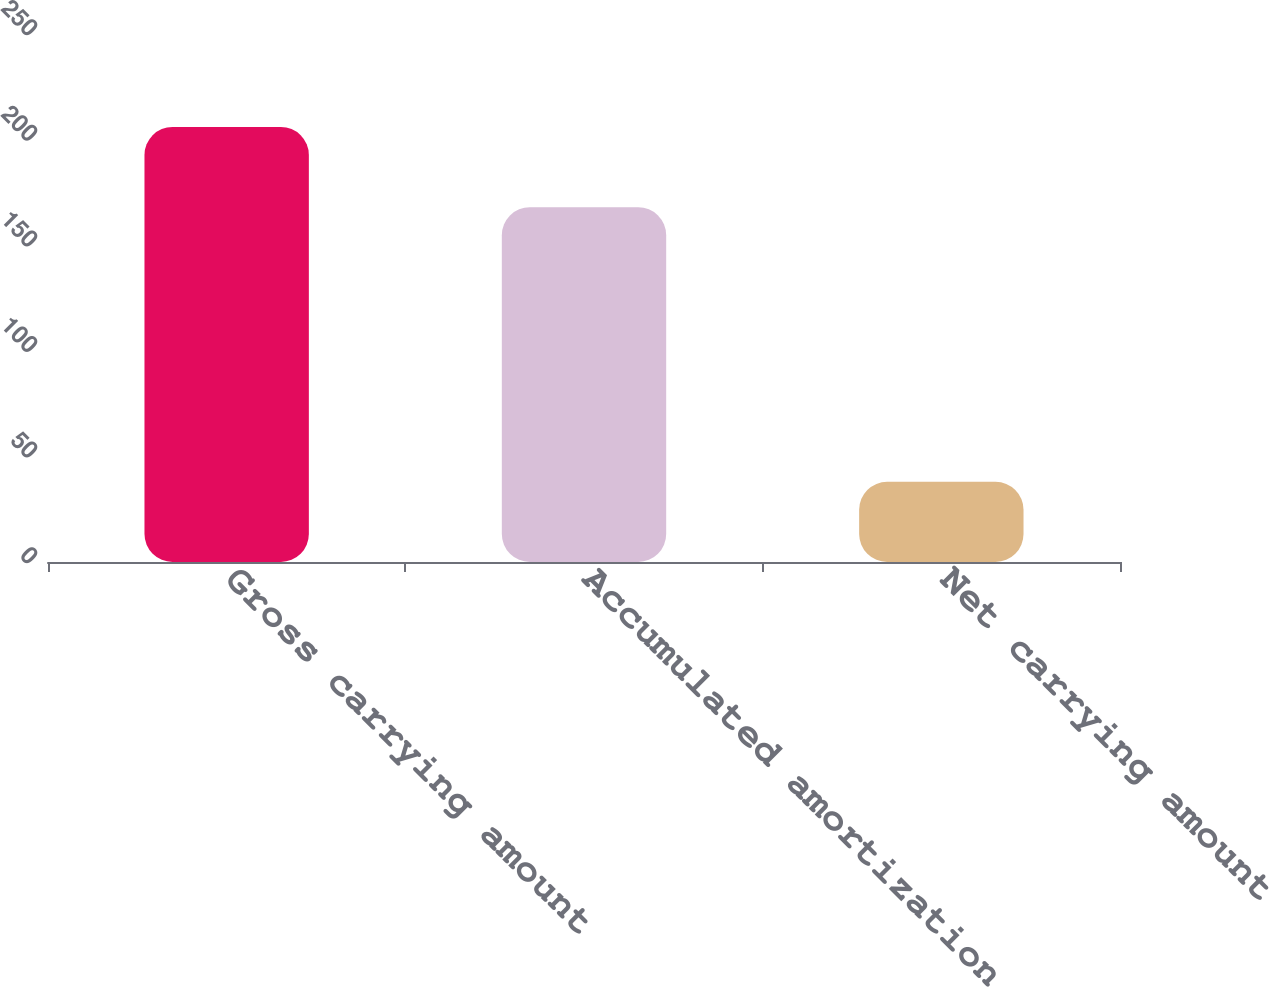Convert chart to OTSL. <chart><loc_0><loc_0><loc_500><loc_500><bar_chart><fcel>Gross carrying amount<fcel>Accumulated amortization<fcel>Net carrying amount<nl><fcel>206<fcel>168<fcel>38<nl></chart> 